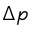<formula> <loc_0><loc_0><loc_500><loc_500>\Delta p</formula> 